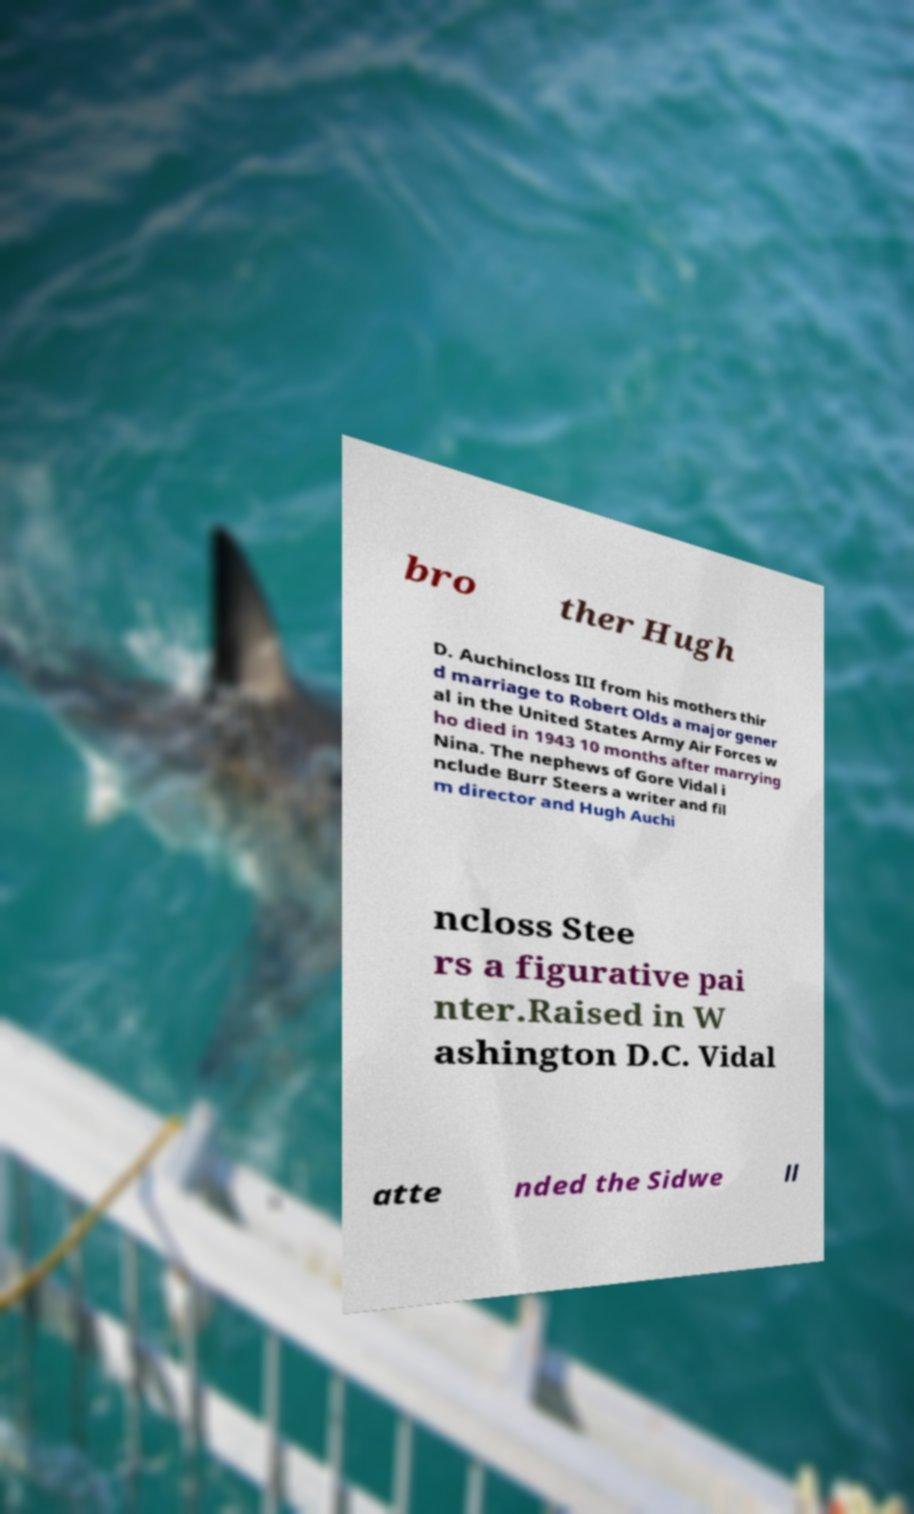Please identify and transcribe the text found in this image. bro ther Hugh D. Auchincloss III from his mothers thir d marriage to Robert Olds a major gener al in the United States Army Air Forces w ho died in 1943 10 months after marrying Nina. The nephews of Gore Vidal i nclude Burr Steers a writer and fil m director and Hugh Auchi ncloss Stee rs a figurative pai nter.Raised in W ashington D.C. Vidal atte nded the Sidwe ll 